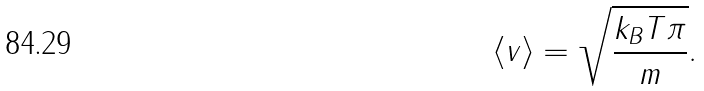Convert formula to latex. <formula><loc_0><loc_0><loc_500><loc_500>\langle v \rangle = \sqrt { \frac { k _ { B } T \pi } { m } } .</formula> 